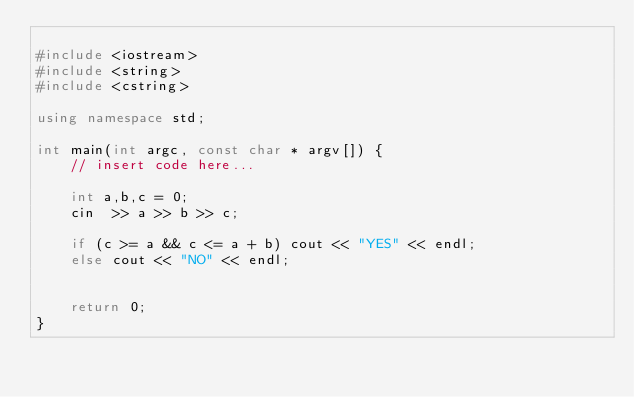Convert code to text. <code><loc_0><loc_0><loc_500><loc_500><_C++_>
#include <iostream>
#include <string>
#include <cstring>

using namespace std;

int main(int argc, const char * argv[]) {
    // insert code here...
    
    int a,b,c = 0;
    cin  >> a >> b >> c;
    
    if (c >= a && c <= a + b) cout << "YES" << endl;
    else cout << "NO" << endl;
    
    
    return 0;
}</code> 